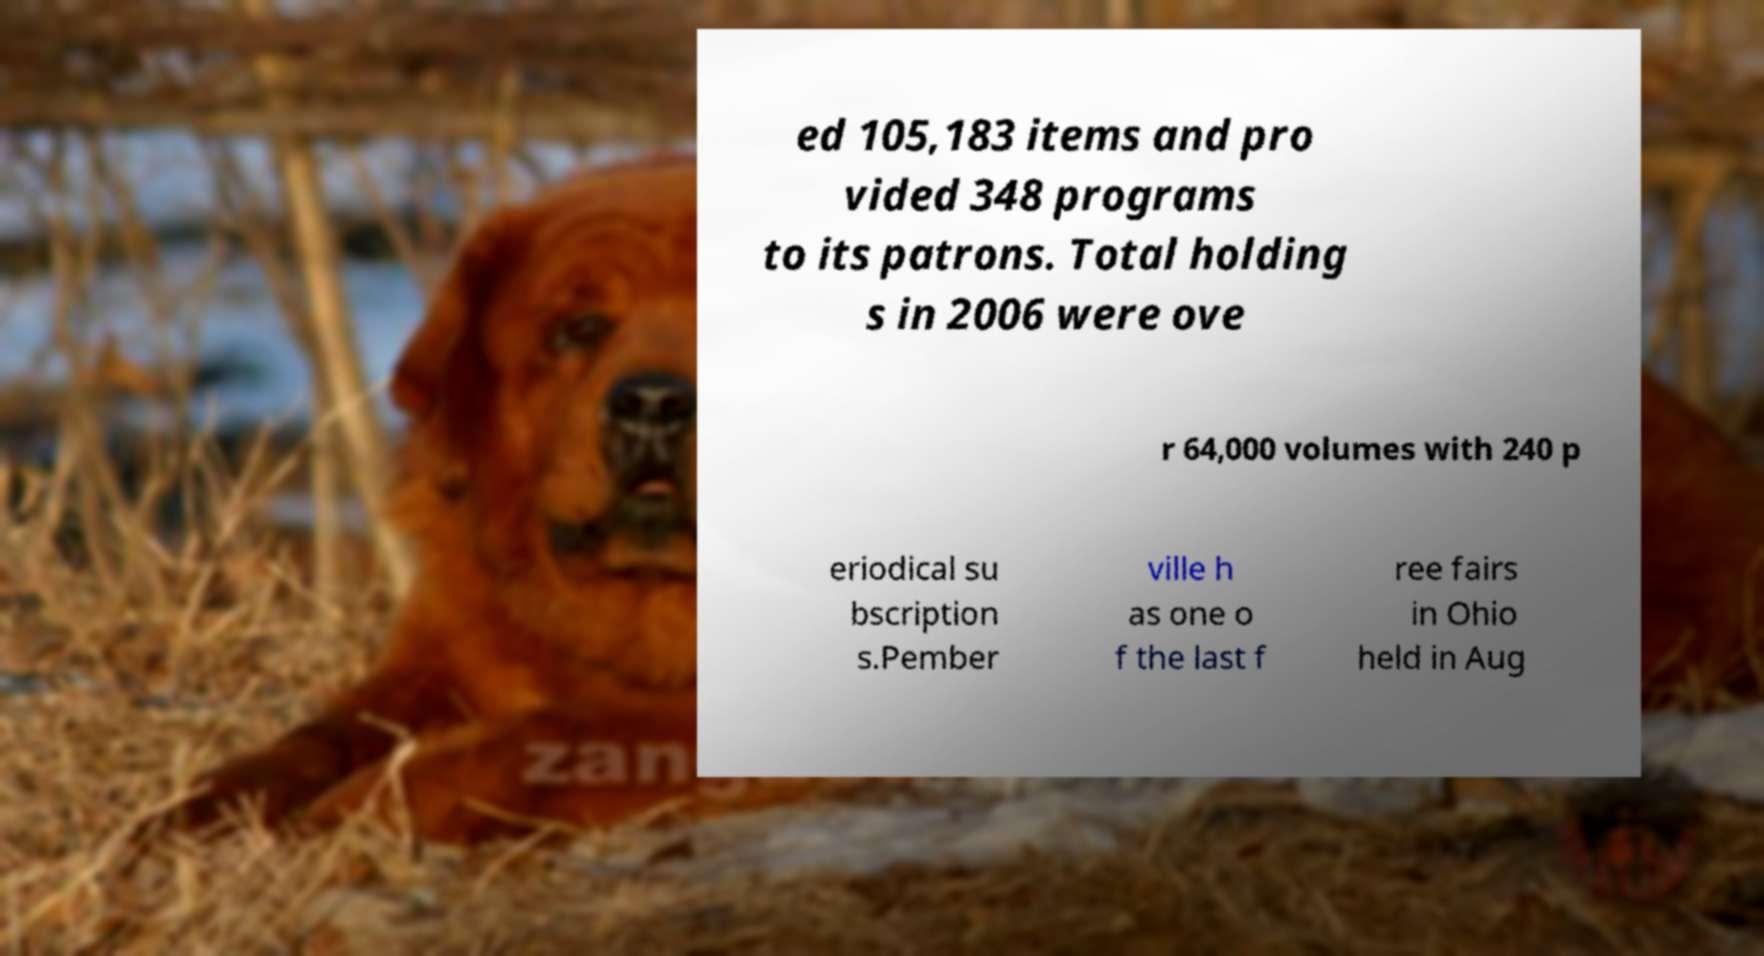Please identify and transcribe the text found in this image. ed 105,183 items and pro vided 348 programs to its patrons. Total holding s in 2006 were ove r 64,000 volumes with 240 p eriodical su bscription s.Pember ville h as one o f the last f ree fairs in Ohio held in Aug 